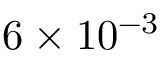Convert formula to latex. <formula><loc_0><loc_0><loc_500><loc_500>6 \times 1 0 ^ { - 3 }</formula> 